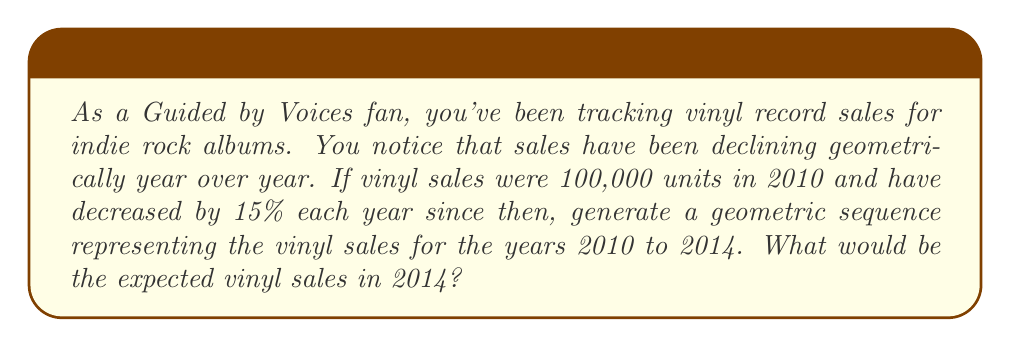Give your solution to this math problem. Let's approach this step-by-step:

1) First, we need to identify our initial value and common ratio:
   - Initial value (a) = 100,000 (sales in 2010)
   - Common ratio (r) = 1 - 0.15 = 0.85 (15% decrease each year)

2) The geometric sequence formula is:
   $a_n = a \cdot r^{n-1}$
   where $a_n$ is the nth term, $a$ is the initial value, $r$ is the common ratio, and $n$ is the term number.

3) Let's calculate each year's sales:

   2010 (n=1): $a_1 = 100,000 \cdot 0.85^{1-1} = 100,000$
   2011 (n=2): $a_2 = 100,000 \cdot 0.85^{2-1} = 85,000$
   2012 (n=3): $a_3 = 100,000 \cdot 0.85^{3-1} = 72,250$
   2013 (n=4): $a_4 = 100,000 \cdot 0.85^{4-1} = 61,412.5$
   2014 (n=5): $a_5 = 100,000 \cdot 0.85^{5-1} = 52,200.625$

4) The geometric sequence is:
   100,000, 85,000, 72,250, 61,412.5, 52,200.625

5) The expected vinyl sales in 2014 would be 52,200.625 units.
Answer: 52,201 units 